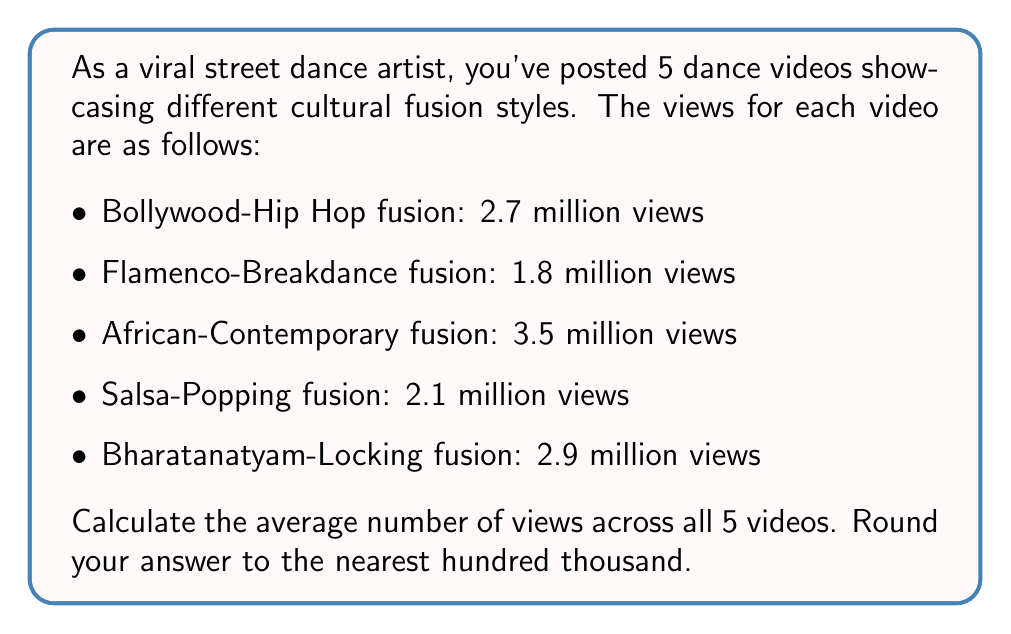Teach me how to tackle this problem. To calculate the average number of views, we need to:
1. Sum up the total views from all videos
2. Divide the sum by the number of videos

Let's follow these steps:

1. Sum of views:
   $$ 2.7 + 1.8 + 3.5 + 2.1 + 2.9 = 13.0 \text{ million views} $$

2. Divide by the number of videos:
   $$ \text{Average} = \frac{\text{Sum of views}}{\text{Number of videos}} = \frac{13.0}{5} = 2.6 \text{ million views} $$

3. Rounding to the nearest hundred thousand:
   2.6 million rounds to 2.6 million (as it's already at a hundred thousand interval)

Therefore, the average number of views across all 5 videos, rounded to the nearest hundred thousand, is 2.6 million views.
Answer: 2.6 million views 